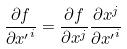Convert formula to latex. <formula><loc_0><loc_0><loc_500><loc_500>\frac { \partial f } { \partial { x ^ { \prime } } ^ { i } } = \frac { \partial f } { \partial x ^ { j } } \frac { \partial x ^ { j } } { \partial { x ^ { \prime } } ^ { i } }</formula> 